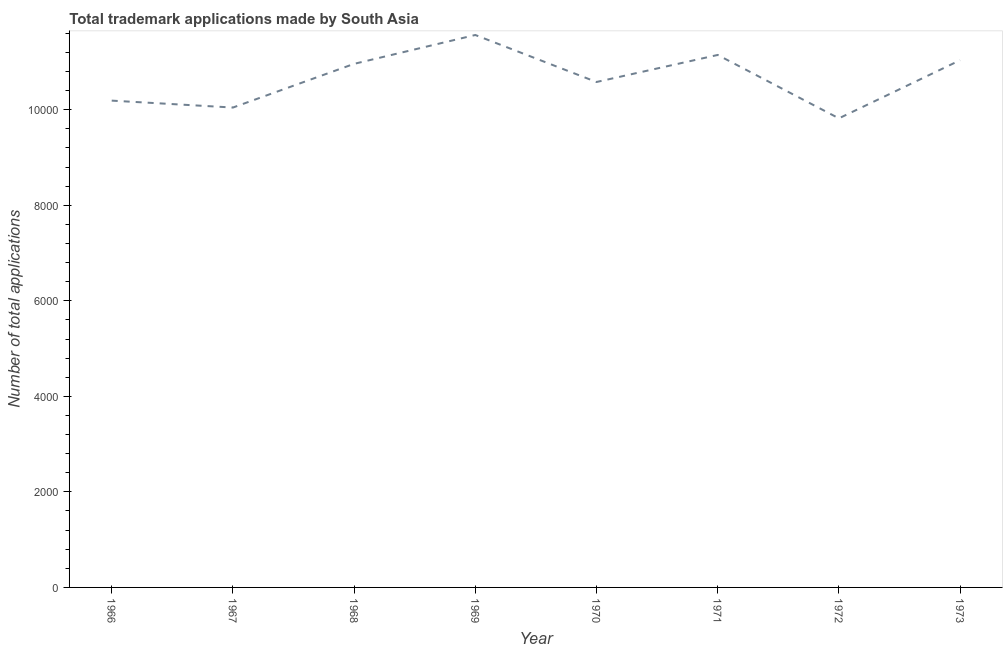What is the number of trademark applications in 1971?
Ensure brevity in your answer.  1.11e+04. Across all years, what is the maximum number of trademark applications?
Your answer should be compact. 1.16e+04. Across all years, what is the minimum number of trademark applications?
Your answer should be compact. 9820. In which year was the number of trademark applications maximum?
Keep it short and to the point. 1969. In which year was the number of trademark applications minimum?
Your answer should be compact. 1972. What is the sum of the number of trademark applications?
Your response must be concise. 8.53e+04. What is the difference between the number of trademark applications in 1966 and 1967?
Offer a very short reply. 145. What is the average number of trademark applications per year?
Your answer should be very brief. 1.07e+04. What is the median number of trademark applications?
Make the answer very short. 1.08e+04. In how many years, is the number of trademark applications greater than 10000 ?
Keep it short and to the point. 7. Do a majority of the years between 1966 and 1973 (inclusive) have number of trademark applications greater than 400 ?
Your response must be concise. Yes. What is the ratio of the number of trademark applications in 1967 to that in 1973?
Offer a very short reply. 0.91. Is the difference between the number of trademark applications in 1970 and 1973 greater than the difference between any two years?
Your answer should be very brief. No. What is the difference between the highest and the second highest number of trademark applications?
Your response must be concise. 418. What is the difference between the highest and the lowest number of trademark applications?
Keep it short and to the point. 1745. How many lines are there?
Provide a succinct answer. 1. Are the values on the major ticks of Y-axis written in scientific E-notation?
Your answer should be compact. No. Does the graph contain grids?
Provide a succinct answer. No. What is the title of the graph?
Provide a succinct answer. Total trademark applications made by South Asia. What is the label or title of the Y-axis?
Provide a succinct answer. Number of total applications. What is the Number of total applications in 1966?
Offer a very short reply. 1.02e+04. What is the Number of total applications in 1967?
Make the answer very short. 1.00e+04. What is the Number of total applications in 1968?
Offer a terse response. 1.10e+04. What is the Number of total applications of 1969?
Your answer should be very brief. 1.16e+04. What is the Number of total applications in 1970?
Make the answer very short. 1.06e+04. What is the Number of total applications in 1971?
Offer a terse response. 1.11e+04. What is the Number of total applications in 1972?
Offer a terse response. 9820. What is the Number of total applications in 1973?
Offer a very short reply. 1.10e+04. What is the difference between the Number of total applications in 1966 and 1967?
Provide a succinct answer. 145. What is the difference between the Number of total applications in 1966 and 1968?
Ensure brevity in your answer.  -770. What is the difference between the Number of total applications in 1966 and 1969?
Ensure brevity in your answer.  -1374. What is the difference between the Number of total applications in 1966 and 1970?
Offer a very short reply. -390. What is the difference between the Number of total applications in 1966 and 1971?
Your answer should be compact. -956. What is the difference between the Number of total applications in 1966 and 1972?
Ensure brevity in your answer.  371. What is the difference between the Number of total applications in 1966 and 1973?
Ensure brevity in your answer.  -846. What is the difference between the Number of total applications in 1967 and 1968?
Offer a terse response. -915. What is the difference between the Number of total applications in 1967 and 1969?
Ensure brevity in your answer.  -1519. What is the difference between the Number of total applications in 1967 and 1970?
Provide a succinct answer. -535. What is the difference between the Number of total applications in 1967 and 1971?
Provide a short and direct response. -1101. What is the difference between the Number of total applications in 1967 and 1972?
Give a very brief answer. 226. What is the difference between the Number of total applications in 1967 and 1973?
Offer a very short reply. -991. What is the difference between the Number of total applications in 1968 and 1969?
Provide a succinct answer. -604. What is the difference between the Number of total applications in 1968 and 1970?
Your answer should be compact. 380. What is the difference between the Number of total applications in 1968 and 1971?
Provide a succinct answer. -186. What is the difference between the Number of total applications in 1968 and 1972?
Your response must be concise. 1141. What is the difference between the Number of total applications in 1968 and 1973?
Your answer should be compact. -76. What is the difference between the Number of total applications in 1969 and 1970?
Your answer should be compact. 984. What is the difference between the Number of total applications in 1969 and 1971?
Provide a succinct answer. 418. What is the difference between the Number of total applications in 1969 and 1972?
Provide a succinct answer. 1745. What is the difference between the Number of total applications in 1969 and 1973?
Your response must be concise. 528. What is the difference between the Number of total applications in 1970 and 1971?
Keep it short and to the point. -566. What is the difference between the Number of total applications in 1970 and 1972?
Your answer should be very brief. 761. What is the difference between the Number of total applications in 1970 and 1973?
Ensure brevity in your answer.  -456. What is the difference between the Number of total applications in 1971 and 1972?
Ensure brevity in your answer.  1327. What is the difference between the Number of total applications in 1971 and 1973?
Make the answer very short. 110. What is the difference between the Number of total applications in 1972 and 1973?
Keep it short and to the point. -1217. What is the ratio of the Number of total applications in 1966 to that in 1968?
Your answer should be compact. 0.93. What is the ratio of the Number of total applications in 1966 to that in 1969?
Your answer should be very brief. 0.88. What is the ratio of the Number of total applications in 1966 to that in 1970?
Provide a short and direct response. 0.96. What is the ratio of the Number of total applications in 1966 to that in 1971?
Make the answer very short. 0.91. What is the ratio of the Number of total applications in 1966 to that in 1972?
Give a very brief answer. 1.04. What is the ratio of the Number of total applications in 1966 to that in 1973?
Your response must be concise. 0.92. What is the ratio of the Number of total applications in 1967 to that in 1968?
Your answer should be very brief. 0.92. What is the ratio of the Number of total applications in 1967 to that in 1969?
Give a very brief answer. 0.87. What is the ratio of the Number of total applications in 1967 to that in 1970?
Provide a succinct answer. 0.95. What is the ratio of the Number of total applications in 1967 to that in 1971?
Your answer should be compact. 0.9. What is the ratio of the Number of total applications in 1967 to that in 1973?
Offer a very short reply. 0.91. What is the ratio of the Number of total applications in 1968 to that in 1969?
Offer a very short reply. 0.95. What is the ratio of the Number of total applications in 1968 to that in 1970?
Provide a succinct answer. 1.04. What is the ratio of the Number of total applications in 1968 to that in 1971?
Provide a succinct answer. 0.98. What is the ratio of the Number of total applications in 1968 to that in 1972?
Give a very brief answer. 1.12. What is the ratio of the Number of total applications in 1968 to that in 1973?
Your answer should be very brief. 0.99. What is the ratio of the Number of total applications in 1969 to that in 1970?
Provide a short and direct response. 1.09. What is the ratio of the Number of total applications in 1969 to that in 1971?
Your answer should be compact. 1.04. What is the ratio of the Number of total applications in 1969 to that in 1972?
Keep it short and to the point. 1.18. What is the ratio of the Number of total applications in 1969 to that in 1973?
Your answer should be very brief. 1.05. What is the ratio of the Number of total applications in 1970 to that in 1971?
Make the answer very short. 0.95. What is the ratio of the Number of total applications in 1970 to that in 1972?
Your answer should be very brief. 1.08. What is the ratio of the Number of total applications in 1971 to that in 1972?
Your answer should be very brief. 1.14. What is the ratio of the Number of total applications in 1972 to that in 1973?
Your response must be concise. 0.89. 